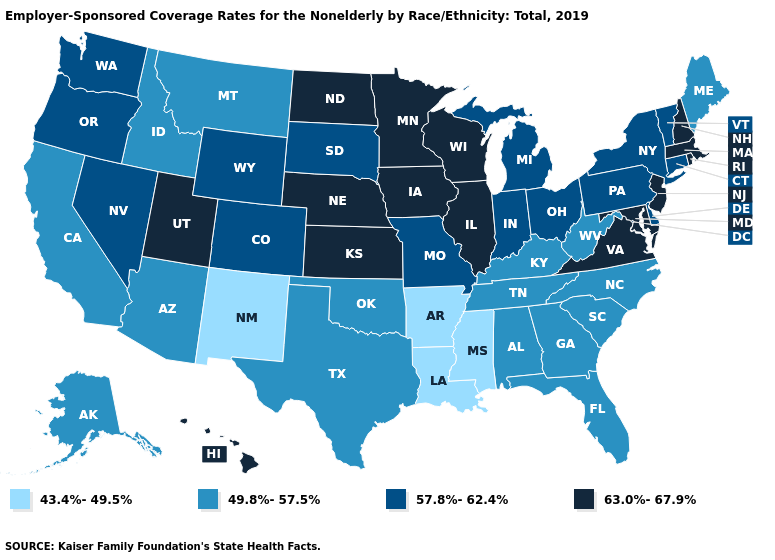What is the lowest value in states that border South Carolina?
Concise answer only. 49.8%-57.5%. Name the states that have a value in the range 63.0%-67.9%?
Give a very brief answer. Hawaii, Illinois, Iowa, Kansas, Maryland, Massachusetts, Minnesota, Nebraska, New Hampshire, New Jersey, North Dakota, Rhode Island, Utah, Virginia, Wisconsin. What is the lowest value in states that border Arizona?
Short answer required. 43.4%-49.5%. Does North Carolina have a higher value than Louisiana?
Concise answer only. Yes. How many symbols are there in the legend?
Concise answer only. 4. Name the states that have a value in the range 57.8%-62.4%?
Keep it brief. Colorado, Connecticut, Delaware, Indiana, Michigan, Missouri, Nevada, New York, Ohio, Oregon, Pennsylvania, South Dakota, Vermont, Washington, Wyoming. Name the states that have a value in the range 49.8%-57.5%?
Answer briefly. Alabama, Alaska, Arizona, California, Florida, Georgia, Idaho, Kentucky, Maine, Montana, North Carolina, Oklahoma, South Carolina, Tennessee, Texas, West Virginia. Among the states that border California , which have the highest value?
Short answer required. Nevada, Oregon. Does the map have missing data?
Give a very brief answer. No. What is the highest value in the USA?
Write a very short answer. 63.0%-67.9%. What is the value of Hawaii?
Answer briefly. 63.0%-67.9%. Among the states that border Iowa , which have the lowest value?
Write a very short answer. Missouri, South Dakota. What is the lowest value in the USA?
Write a very short answer. 43.4%-49.5%. Name the states that have a value in the range 57.8%-62.4%?
Write a very short answer. Colorado, Connecticut, Delaware, Indiana, Michigan, Missouri, Nevada, New York, Ohio, Oregon, Pennsylvania, South Dakota, Vermont, Washington, Wyoming. What is the value of Minnesota?
Concise answer only. 63.0%-67.9%. 